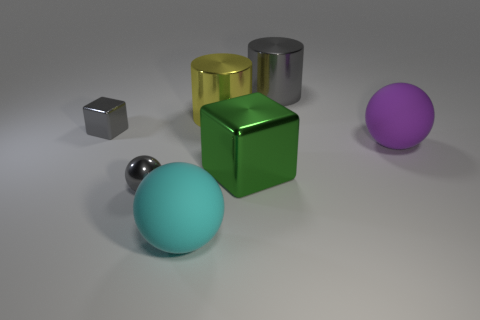Does the small metallic sphere have the same color as the big cube?
Provide a short and direct response. No. Is the shape of the matte thing that is to the left of the gray metallic cylinder the same as  the big green metal object?
Offer a very short reply. No. What number of gray cylinders have the same size as the green thing?
Keep it short and to the point. 1. The tiny metal object that is the same color as the tiny shiny block is what shape?
Provide a short and direct response. Sphere. There is a rubber ball that is on the right side of the big cyan ball; are there any shiny balls that are behind it?
Give a very brief answer. No. How many things are metal blocks right of the cyan rubber thing or large yellow metal cylinders?
Your answer should be compact. 2. What number of big cyan cubes are there?
Give a very brief answer. 0. What shape is the large green thing that is the same material as the large yellow thing?
Your answer should be compact. Cube. There is a gray sphere to the left of the big rubber sphere to the right of the big cyan thing; what is its size?
Keep it short and to the point. Small. What number of objects are either big objects that are behind the small metal cube or small shiny objects that are on the right side of the small gray metallic block?
Ensure brevity in your answer.  3. 